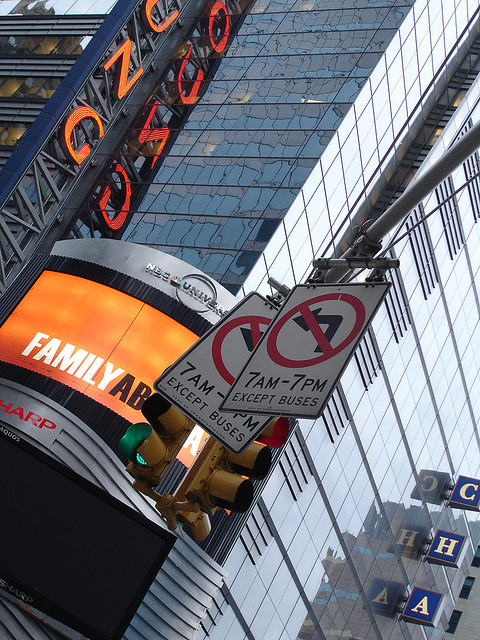Please identify all text content in this image. UNG UNG EXCEPT BUSES EXCEPT SHARP A H C UNIVERS FAMILY HARP BUSES PM 7 am 7PM 7AM 